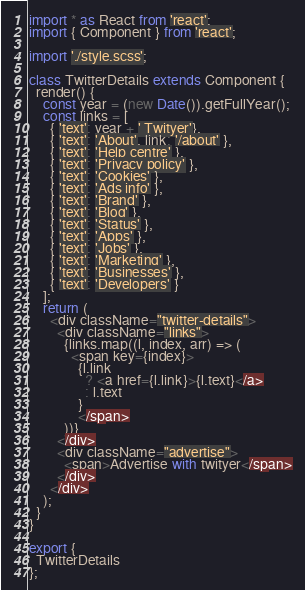<code> <loc_0><loc_0><loc_500><loc_500><_TypeScript_>import * as React from 'react';
import { Component } from 'react';

import './style.scss';

class TwitterDetails extends Component {
  render() {
    const year = (new Date()).getFullYear();
    const links = [
      { 'text': year + ' Twityer'},
      { 'text': 'About', link: '/about' },
      { 'text': 'Help centre' },
      { 'text': 'Privacy policy' },
      { 'text': 'Cookies' },
      { 'text': 'Ads info' },
      { 'text': 'Brand' },
      { 'text': 'Blog' },
      { 'text': 'Status' },
      { 'text': 'Apps' },
      { 'text': 'Jobs' },
      { 'text': 'Marketing' },
      { 'text': 'Businesses' },
      { 'text': 'Developers' }
    ];
    return (
      <div className="twitter-details">
        <div className="links">
          {links.map((l, index, arr) => (
            <span key={index}>
              {l.link 
                ? <a href={l.link}>{l.text}</a>
                : l.text
              }
              </span>
          ))}
        </div>
        <div className="advertise">
          <span>Advertise with twityer</span>
        </div>
      </div>
    );
  }
}

export {
  TwitterDetails
};
</code> 